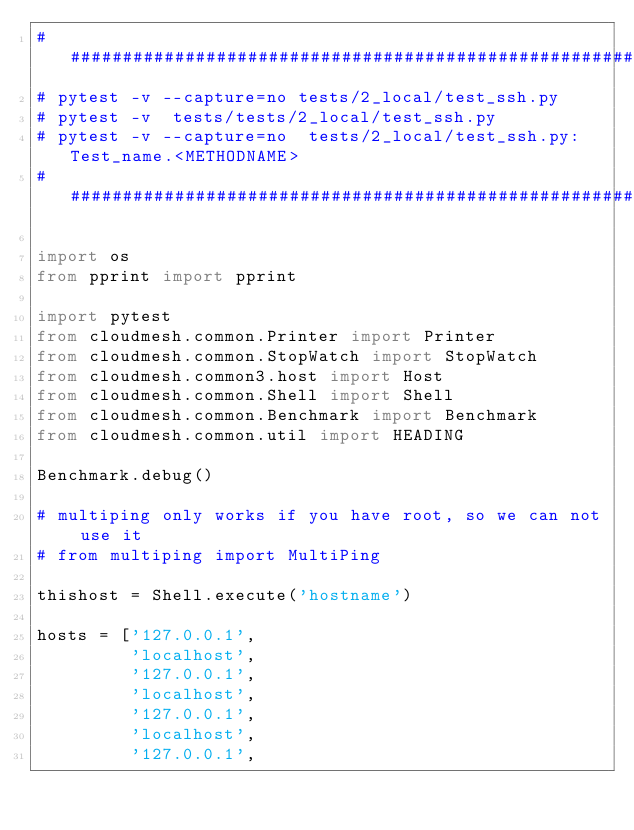<code> <loc_0><loc_0><loc_500><loc_500><_Python_>###############################################################
# pytest -v --capture=no tests/2_local/test_ssh.py
# pytest -v  tests/tests/2_local/test_ssh.py
# pytest -v --capture=no  tests/2_local/test_ssh.py:Test_name.<METHODNAME>
###############################################################

import os
from pprint import pprint

import pytest
from cloudmesh.common.Printer import Printer
from cloudmesh.common.StopWatch import StopWatch
from cloudmesh.common3.host import Host
from cloudmesh.common.Shell import Shell
from cloudmesh.common.Benchmark import Benchmark
from cloudmesh.common.util import HEADING

Benchmark.debug()

# multiping only works if you have root, so we can not use it
# from multiping import MultiPing

thishost = Shell.execute('hostname')

hosts = ['127.0.0.1',
         'localhost',
         '127.0.0.1',
         'localhost',
         '127.0.0.1',
         'localhost',
         '127.0.0.1',</code> 